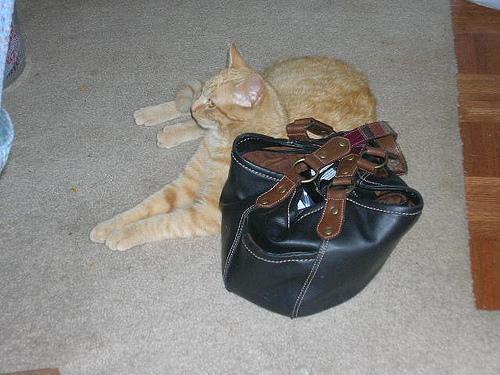How many people can sit here?
Give a very brief answer. 0. 